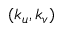Convert formula to latex. <formula><loc_0><loc_0><loc_500><loc_500>( k _ { u } , k _ { v } )</formula> 